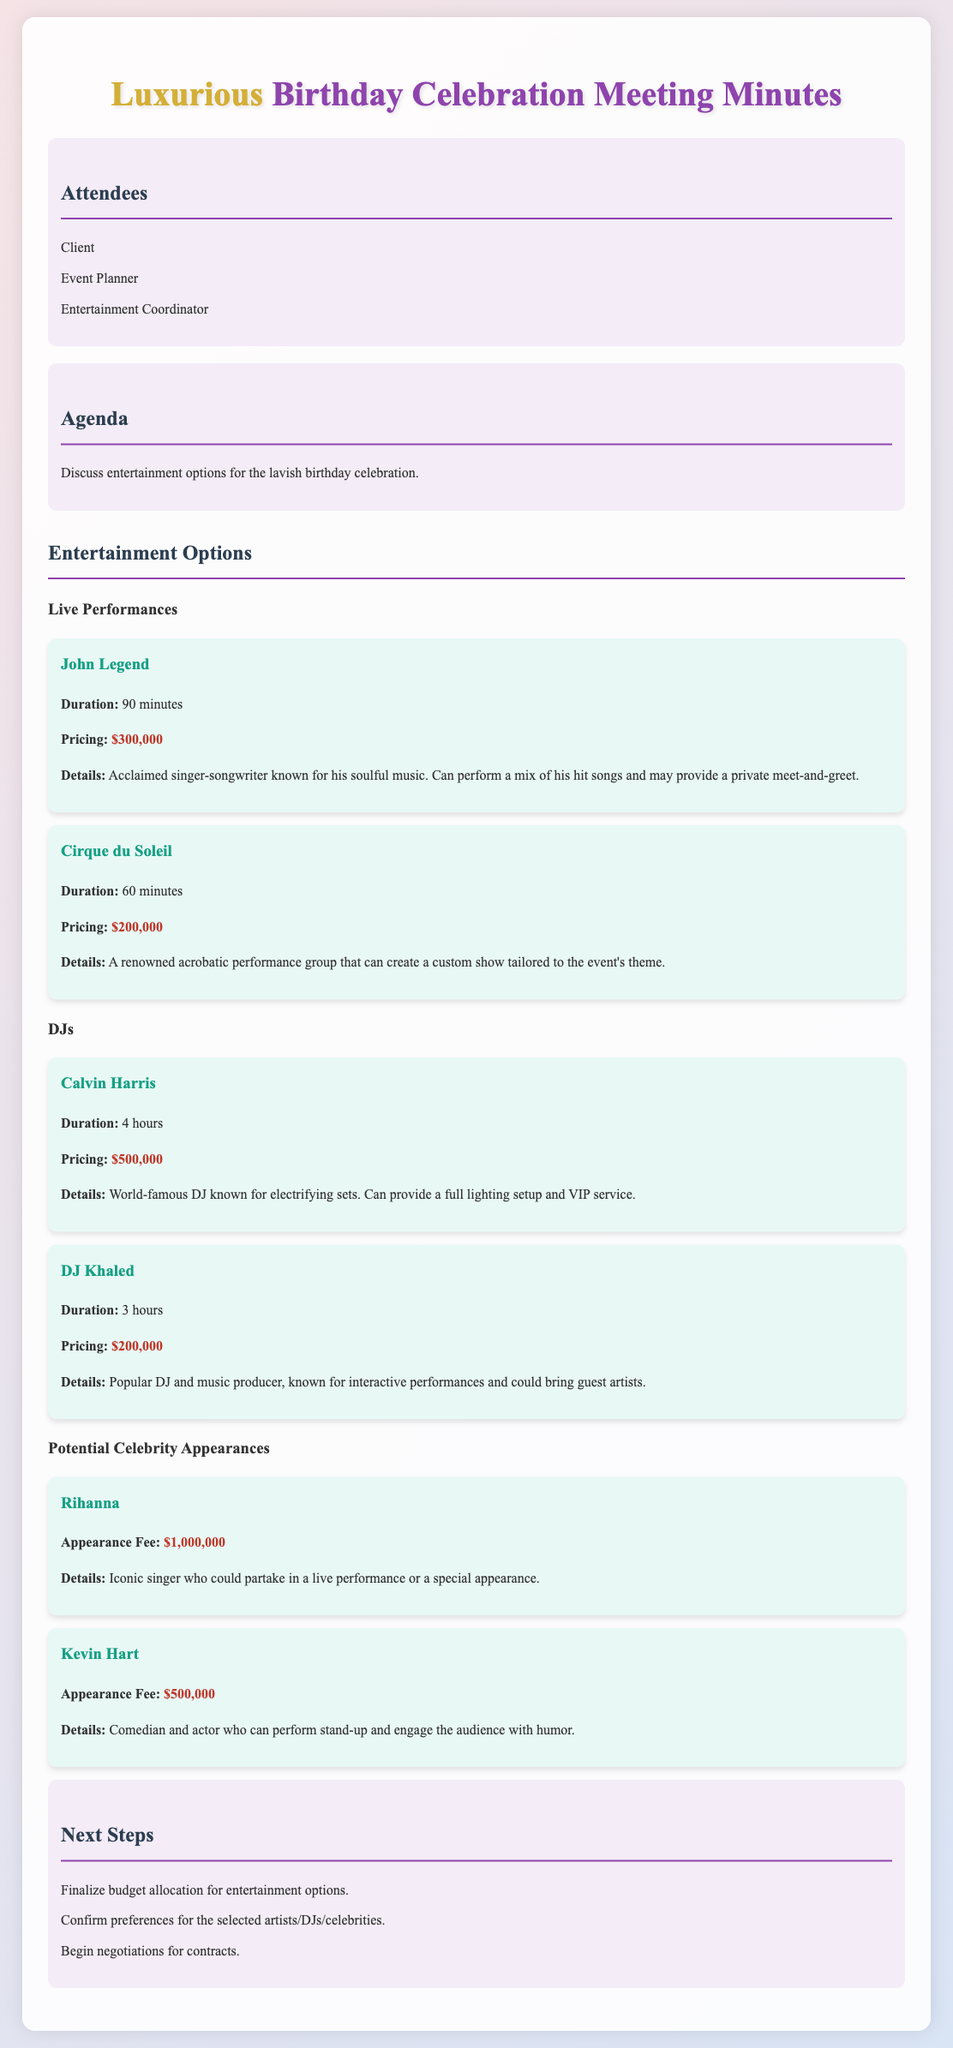What is the duration of the John Legend performance? The document states that the duration of the John Legend performance is 90 minutes.
Answer: 90 minutes What is the pricing for Cirque du Soleil? The document lists the pricing for Cirque du Soleil as $200,000.
Answer: $200,000 What is the appearance fee for Rihanna? The document specifies the appearance fee for Rihanna as $1,000,000.
Answer: $1,000,000 How long will Calvin Harris perform? According to the document, Calvin Harris will perform for 4 hours.
Answer: 4 hours Which DJ has the highest pricing? The document indicates that Calvin Harris has the highest pricing among DJs at $500,000.
Answer: Calvin Harris What type of entertainment does Kevin Hart provide? The document mentions that Kevin Hart can perform stand-up comedy and engage with the audience.
Answer: Stand-up comedy What are the next steps listed in the document? The document outlines the next steps including finalizing budget allocation, confirming preferences, and beginning negotiations.
Answer: Finalize budget allocation, confirm preferences, begin negotiations What is the total duration of the DJ Khaled performance? The document states that DJ Khaled's performance will last for 3 hours.
Answer: 3 hours What is a unique feature of the Cirque du Soleil performance? The document notes that Cirque du Soleil can create a custom show tailored to the event's theme.
Answer: Custom show tailored to the event's theme 